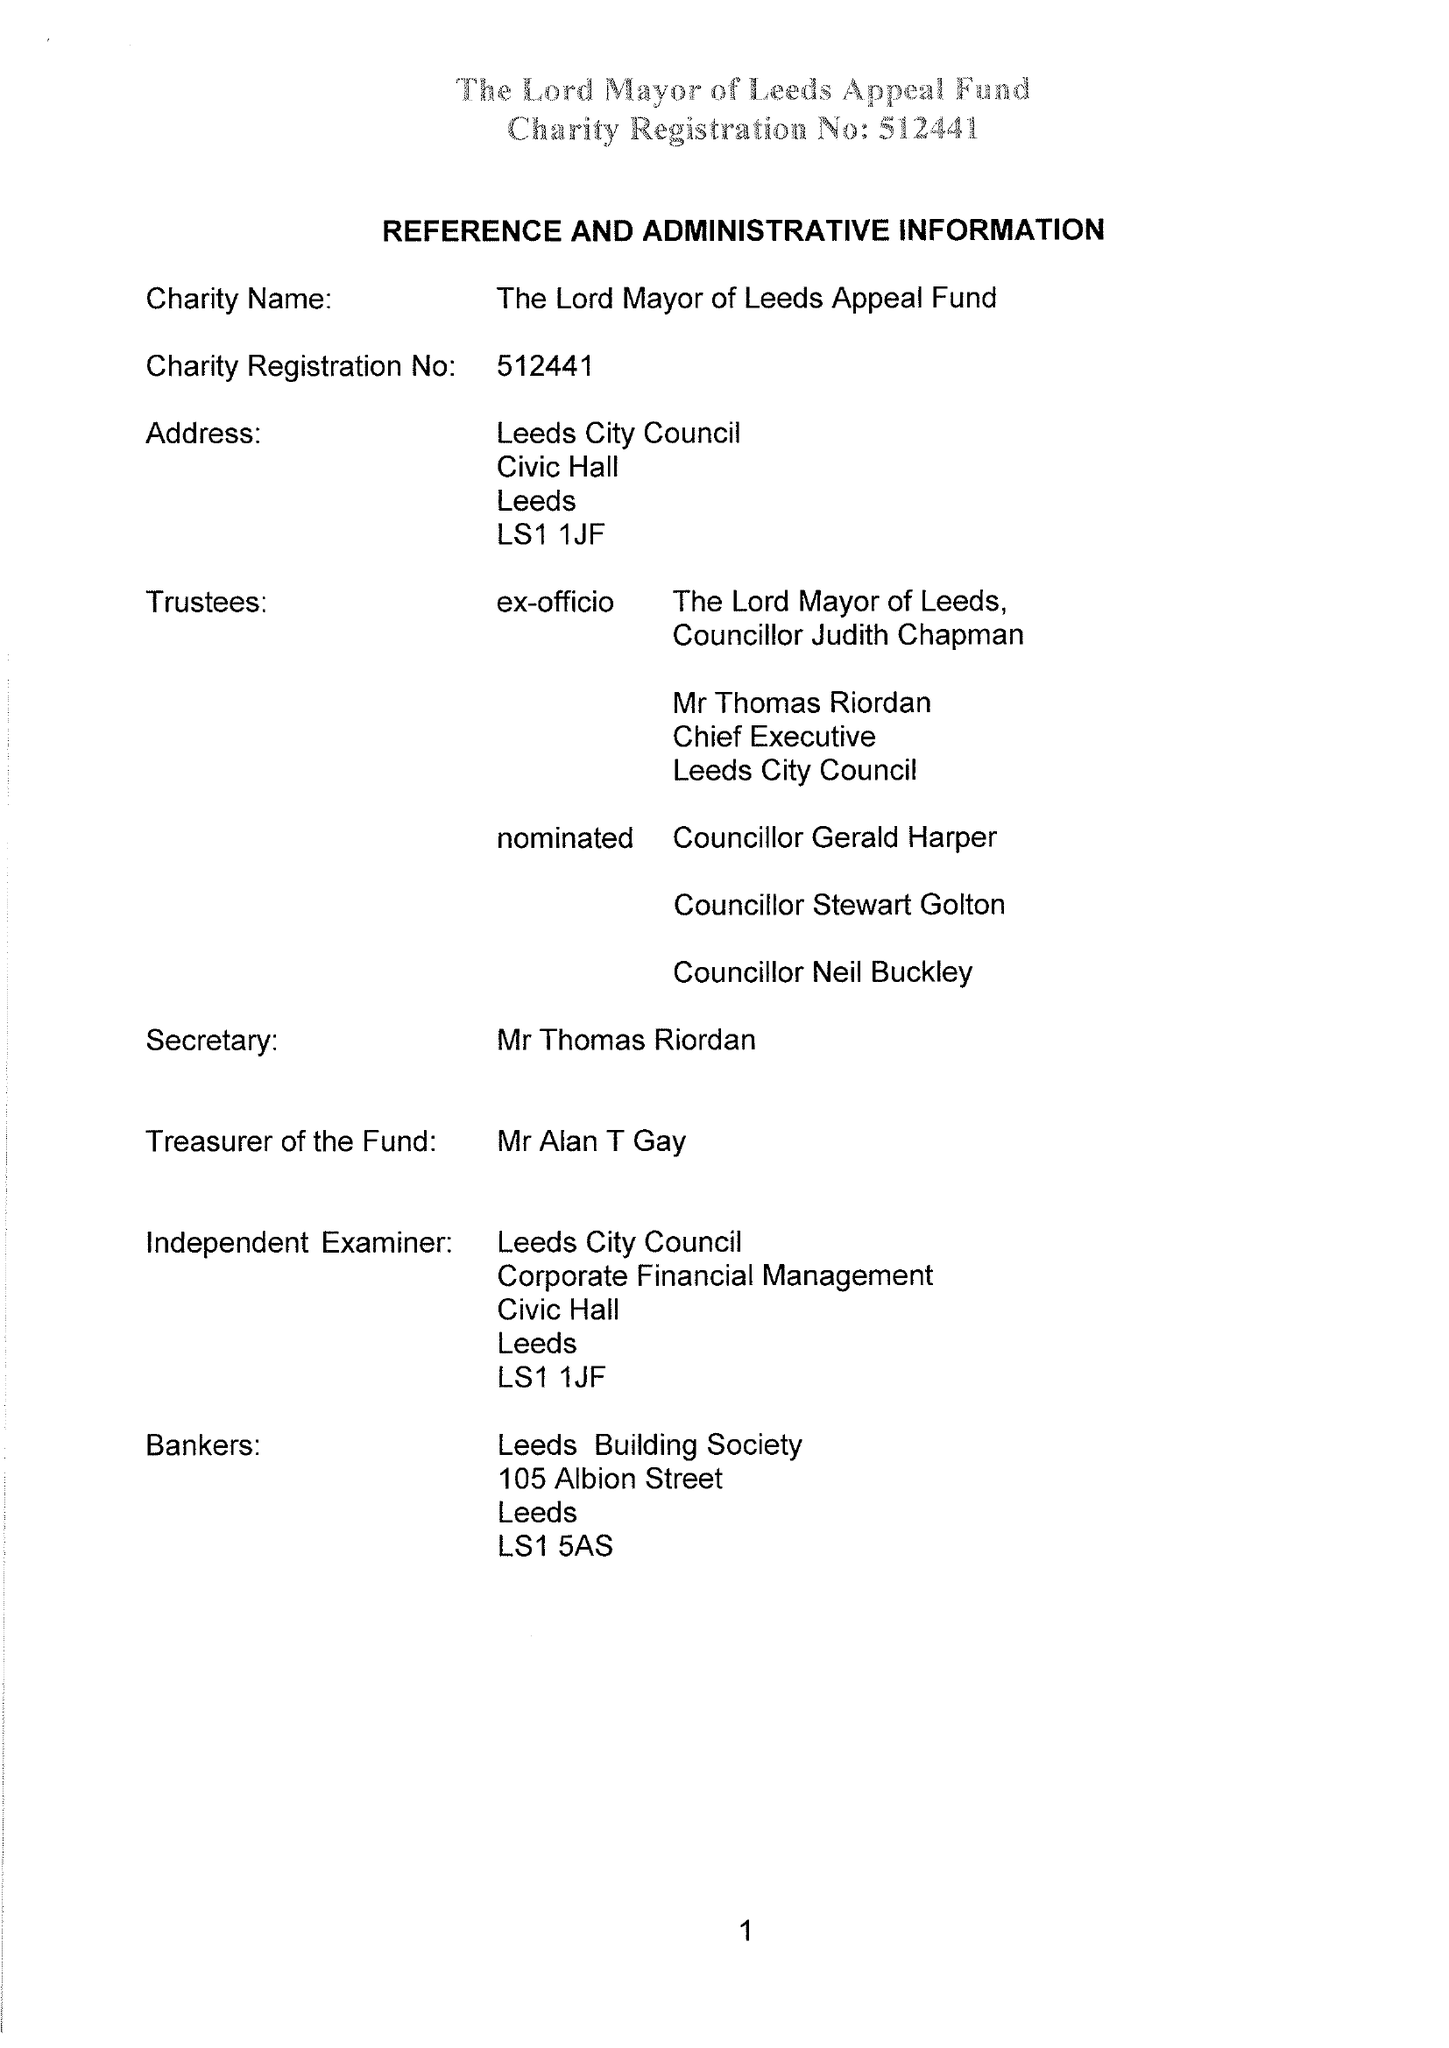What is the value for the address__street_line?
Answer the question using a single word or phrase. None 